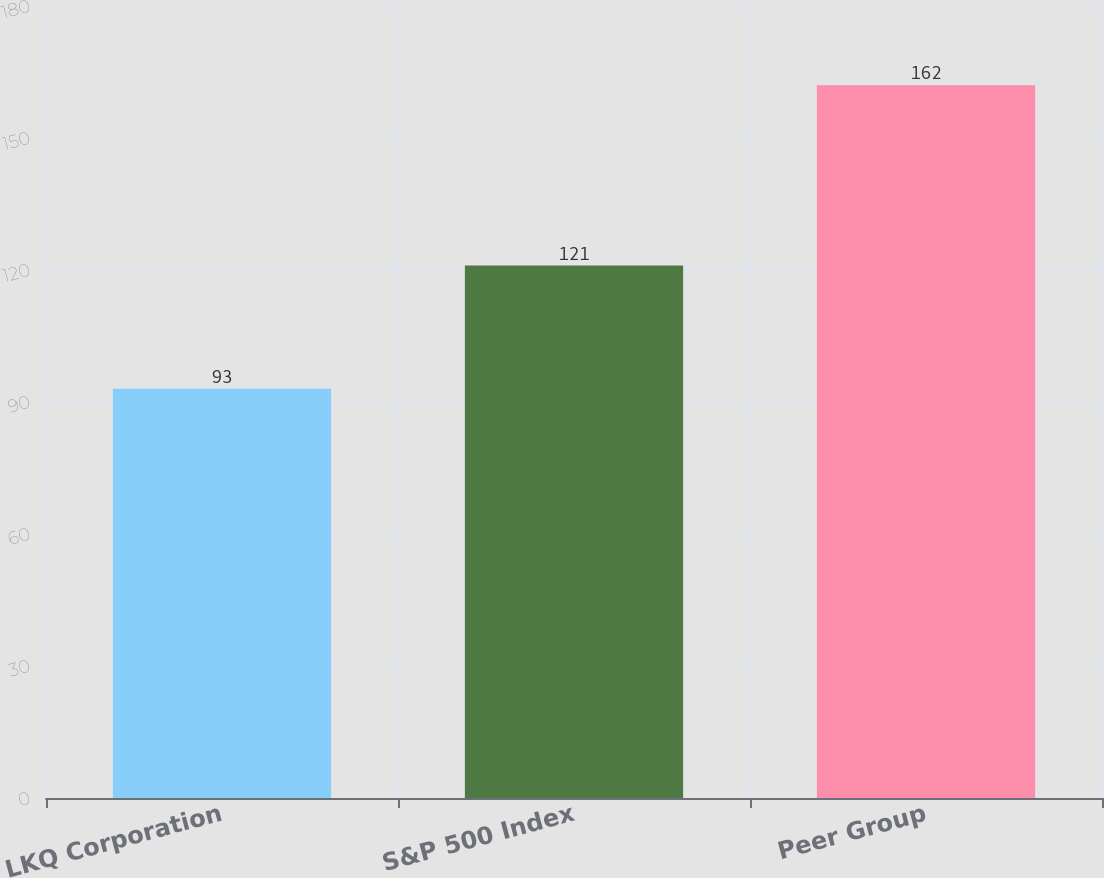Convert chart to OTSL. <chart><loc_0><loc_0><loc_500><loc_500><bar_chart><fcel>LKQ Corporation<fcel>S&P 500 Index<fcel>Peer Group<nl><fcel>93<fcel>121<fcel>162<nl></chart> 